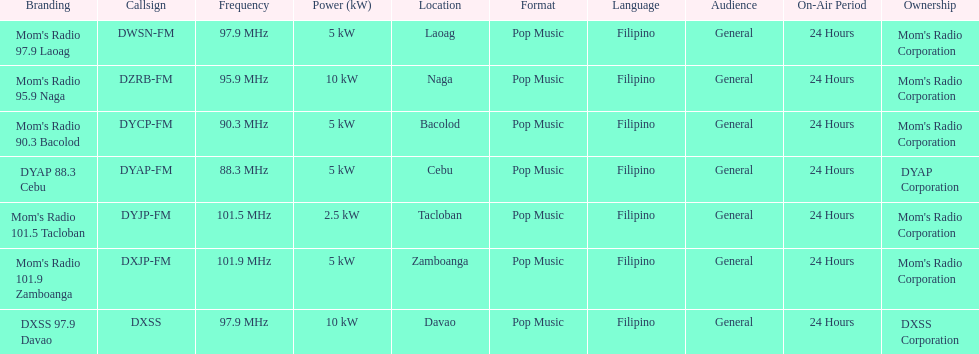What is the total number of stations with frequencies above 100 mhz? 2. 